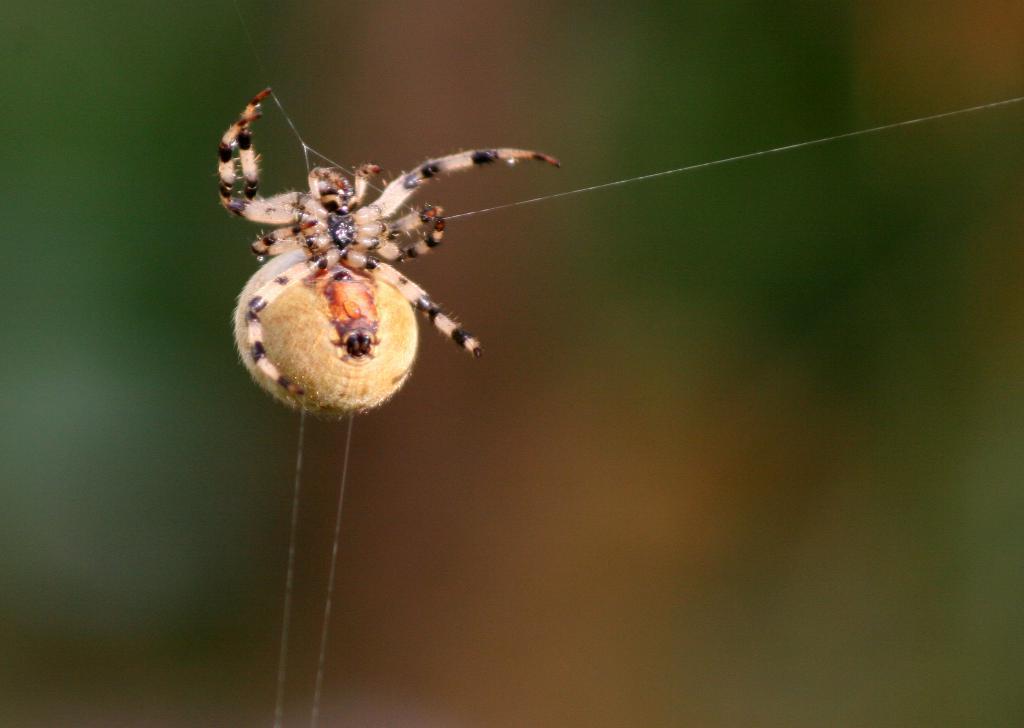Please provide a concise description of this image. In this picture we can see a spider with some amount of spider web. The background of the image is blurry. 